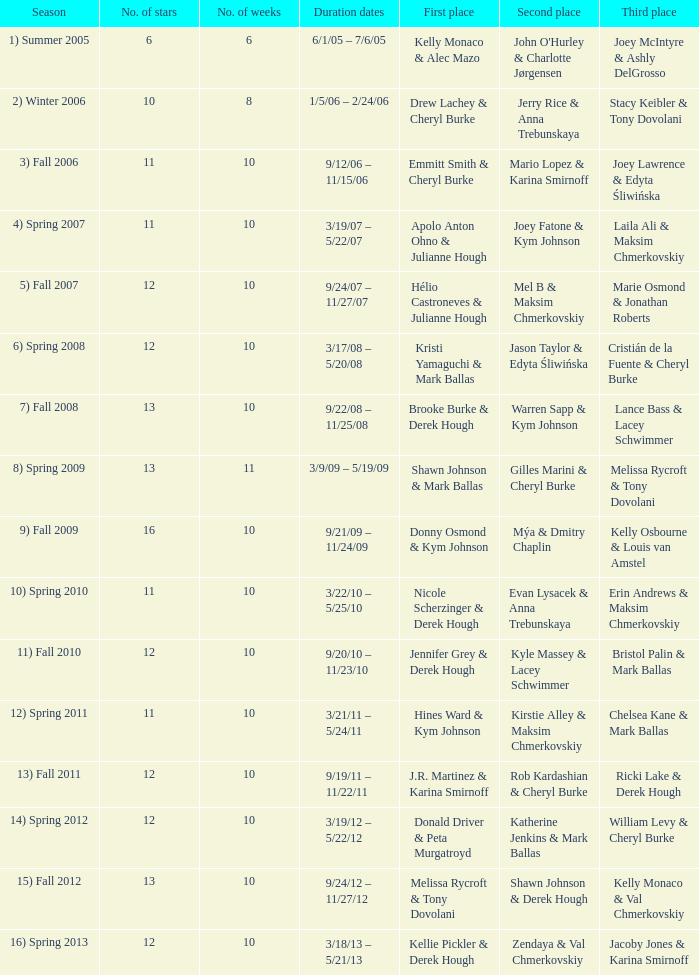Parse the table in full. {'header': ['Season', 'No. of stars', 'No. of weeks', 'Duration dates', 'First place', 'Second place', 'Third place'], 'rows': [['1) Summer 2005', '6', '6', '6/1/05 – 7/6/05', 'Kelly Monaco & Alec Mazo', "John O'Hurley & Charlotte Jørgensen", 'Joey McIntyre & Ashly DelGrosso'], ['2) Winter 2006', '10', '8', '1/5/06 – 2/24/06', 'Drew Lachey & Cheryl Burke', 'Jerry Rice & Anna Trebunskaya', 'Stacy Keibler & Tony Dovolani'], ['3) Fall 2006', '11', '10', '9/12/06 – 11/15/06', 'Emmitt Smith & Cheryl Burke', 'Mario Lopez & Karina Smirnoff', 'Joey Lawrence & Edyta Śliwińska'], ['4) Spring 2007', '11', '10', '3/19/07 – 5/22/07', 'Apolo Anton Ohno & Julianne Hough', 'Joey Fatone & Kym Johnson', 'Laila Ali & Maksim Chmerkovskiy'], ['5) Fall 2007', '12', '10', '9/24/07 – 11/27/07', 'Hélio Castroneves & Julianne Hough', 'Mel B & Maksim Chmerkovskiy', 'Marie Osmond & Jonathan Roberts'], ['6) Spring 2008', '12', '10', '3/17/08 – 5/20/08', 'Kristi Yamaguchi & Mark Ballas', 'Jason Taylor & Edyta Śliwińska', 'Cristián de la Fuente & Cheryl Burke'], ['7) Fall 2008', '13', '10', '9/22/08 – 11/25/08', 'Brooke Burke & Derek Hough', 'Warren Sapp & Kym Johnson', 'Lance Bass & Lacey Schwimmer'], ['8) Spring 2009', '13', '11', '3/9/09 – 5/19/09', 'Shawn Johnson & Mark Ballas', 'Gilles Marini & Cheryl Burke', 'Melissa Rycroft & Tony Dovolani'], ['9) Fall 2009', '16', '10', '9/21/09 – 11/24/09', 'Donny Osmond & Kym Johnson', 'Mýa & Dmitry Chaplin', 'Kelly Osbourne & Louis van Amstel'], ['10) Spring 2010', '11', '10', '3/22/10 – 5/25/10', 'Nicole Scherzinger & Derek Hough', 'Evan Lysacek & Anna Trebunskaya', 'Erin Andrews & Maksim Chmerkovskiy'], ['11) Fall 2010', '12', '10', '9/20/10 – 11/23/10', 'Jennifer Grey & Derek Hough', 'Kyle Massey & Lacey Schwimmer', 'Bristol Palin & Mark Ballas'], ['12) Spring 2011', '11', '10', '3/21/11 – 5/24/11', 'Hines Ward & Kym Johnson', 'Kirstie Alley & Maksim Chmerkovskiy', 'Chelsea Kane & Mark Ballas'], ['13) Fall 2011', '12', '10', '9/19/11 – 11/22/11', 'J.R. Martinez & Karina Smirnoff', 'Rob Kardashian & Cheryl Burke', 'Ricki Lake & Derek Hough'], ['14) Spring 2012', '12', '10', '3/19/12 – 5/22/12', 'Donald Driver & Peta Murgatroyd', 'Katherine Jenkins & Mark Ballas', 'William Levy & Cheryl Burke'], ['15) Fall 2012', '13', '10', '9/24/12 – 11/27/12', 'Melissa Rycroft & Tony Dovolani', 'Shawn Johnson & Derek Hough', 'Kelly Monaco & Val Chmerkovskiy'], ['16) Spring 2013', '12', '10', '3/18/13 – 5/21/13', 'Kellie Pickler & Derek Hough', 'Zendaya & Val Chmerkovskiy', 'Jacoby Jones & Karina Smirnoff']]} Who achieved the first rank in week 6? 1.0. 